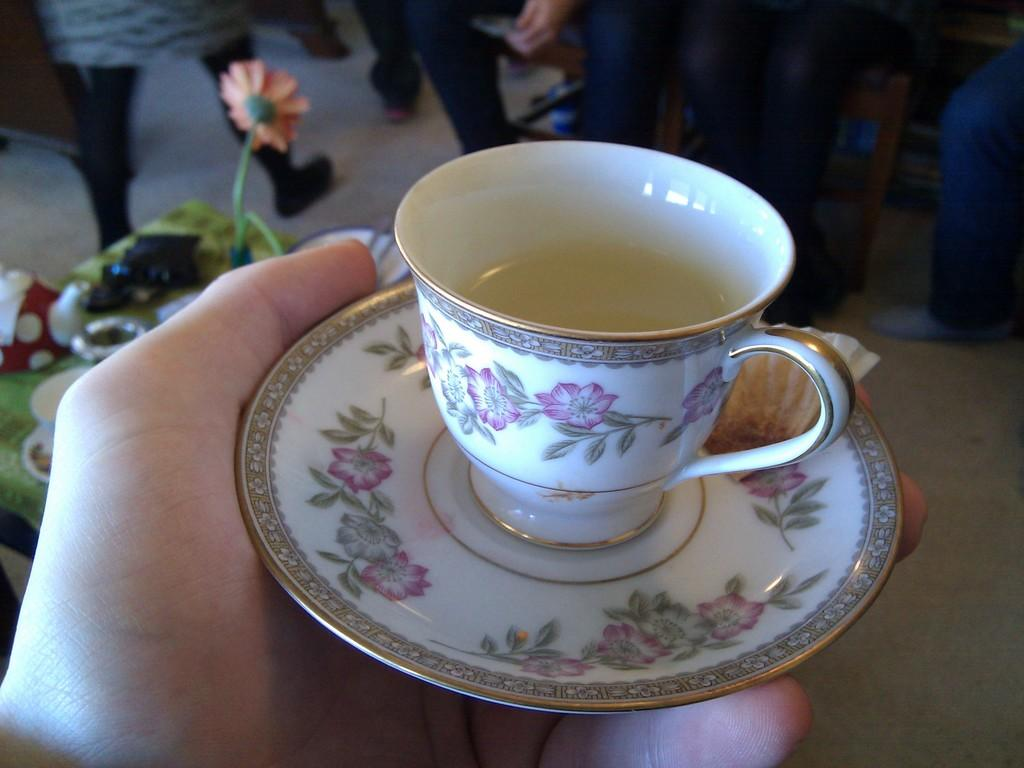What is the person in the image holding? The person is holding a saucer with a cup on it. What can be seen in the background of the image? There is a flower and other items on a table in the background. Are there any other people visible in the image? Yes, there is a group of people in the background. What grade does the person holding the saucer receive for their performance in the image? There is no indication of a performance or grading system in the image, so it cannot be determined. 